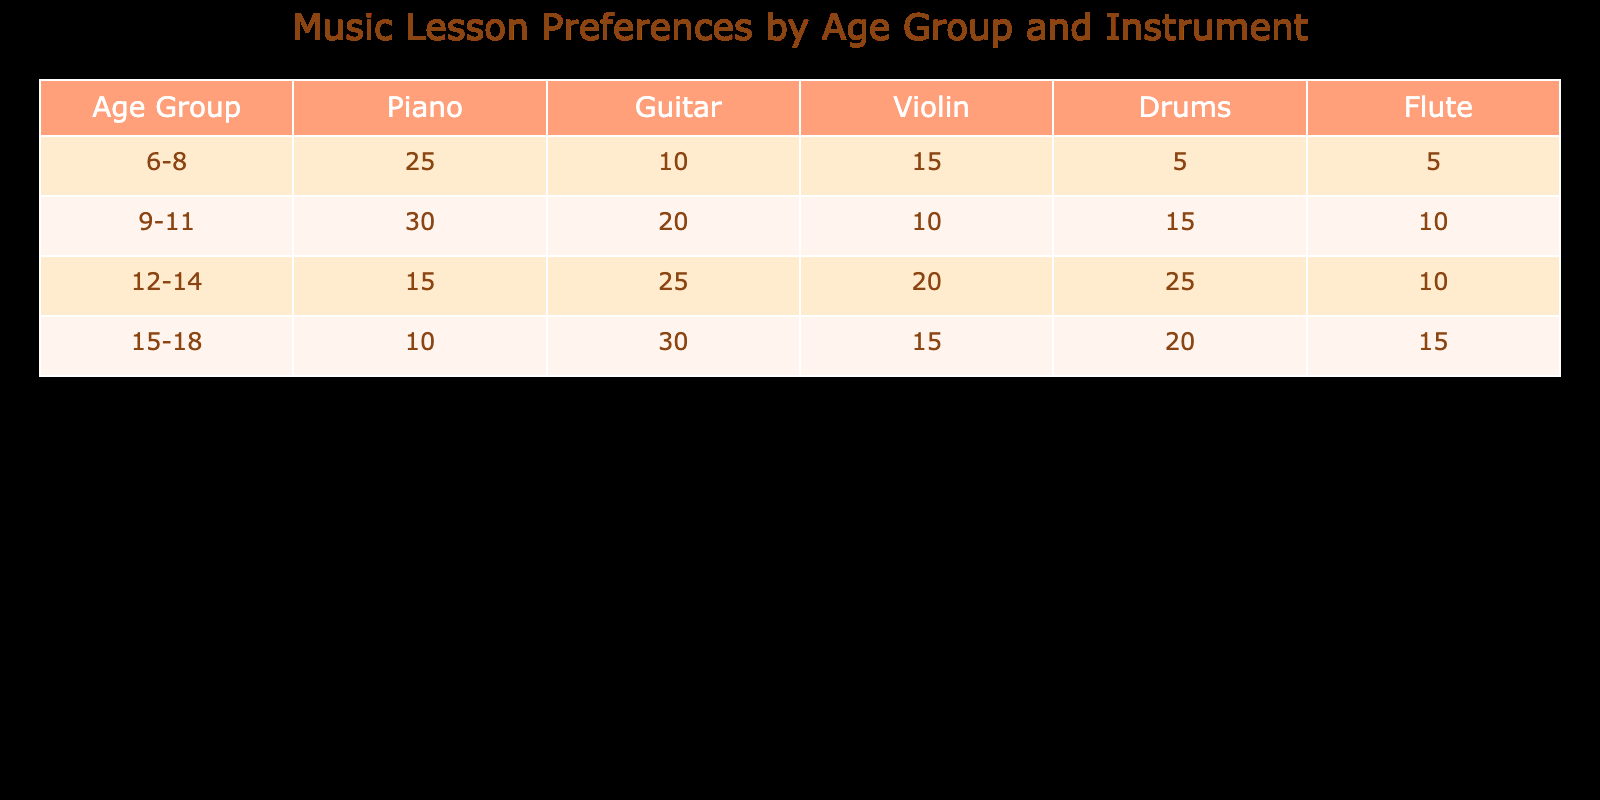What instrument do the 9-11 age group prefer the most? In the 9-11 age group, the instrument with the highest count is the Guitar, with 20 students preferring it.
Answer: Guitar Is it true that more kids aged 15-18 prefer Guitar over Piano? Yes, the count for Guitar is 30, while the count for Piano is 10, confirming that more kids in this age group prefer Guitar.
Answer: Yes What is the total number of students in the 12-14 age group who prefer Drums? For the 12-14 age group, the table shows that 25 students prefer Drums. This is a direct retrieval from the row corresponding to this age group.
Answer: 25 How many more students in the 6-8 age group prefer Violin compared to Flute? In the 6-8 age group, 15 students prefer Violin and 5 prefer Flute. The difference is 15 - 5 = 10, meaning 10 more students prefer Violin.
Answer: 10 What is the average number of students preferring Piano across all age groups? To find the average, we add up the counts for Piano across all age groups: 25 + 30 + 15 + 10 = 80. There are 4 age groups, so the average is 80 / 4 = 20.
Answer: 20 Which age group has the highest preference for Violin? The 12-14 age group has the highest preference for Violin, with a count of 20 students, more than any other age group that is shown in the table.
Answer: 12-14 How many students aged 9-11 prefer instruments other than Guitar? In the 9-11 age group, students prefer the following instruments: Piano (30), Violin (10), Drums (15), and Flute (10). Adding these counts gives 30 + 10 + 15 + 10 = 65.
Answer: 65 Is the total number of students preferring Flute greater in the 15-18 age group than in the 6-8 age group? In the 15-18 age group, 15 students prefer Flute, while in the 6-8 age group, only 5 prefer it. Thus, it is true that the total is greater in the 15-18 age group.
Answer: Yes Which age group has the lowest preference for Drums? The age group 6-8 has the lowest preference for Drums, with only 5 students choosing that instrument, compared to higher counts in older age groups.
Answer: 6-8 